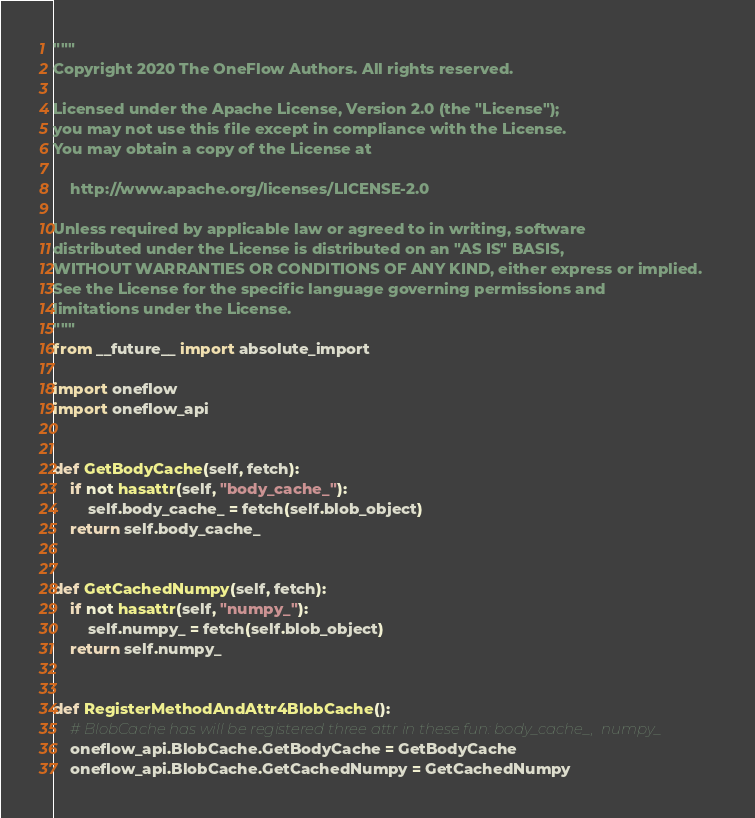Convert code to text. <code><loc_0><loc_0><loc_500><loc_500><_Python_>"""
Copyright 2020 The OneFlow Authors. All rights reserved.

Licensed under the Apache License, Version 2.0 (the "License");
you may not use this file except in compliance with the License.
You may obtain a copy of the License at

    http://www.apache.org/licenses/LICENSE-2.0

Unless required by applicable law or agreed to in writing, software
distributed under the License is distributed on an "AS IS" BASIS,
WITHOUT WARRANTIES OR CONDITIONS OF ANY KIND, either express or implied.
See the License for the specific language governing permissions and
limitations under the License.
"""
from __future__ import absolute_import

import oneflow
import oneflow_api


def GetBodyCache(self, fetch):
    if not hasattr(self, "body_cache_"):
        self.body_cache_ = fetch(self.blob_object)
    return self.body_cache_


def GetCachedNumpy(self, fetch):
    if not hasattr(self, "numpy_"):
        self.numpy_ = fetch(self.blob_object)
    return self.numpy_


def RegisterMethodAndAttr4BlobCache():
    # BlobCache has will be registered three attr in these fun: body_cache_,  numpy_
    oneflow_api.BlobCache.GetBodyCache = GetBodyCache
    oneflow_api.BlobCache.GetCachedNumpy = GetCachedNumpy
</code> 